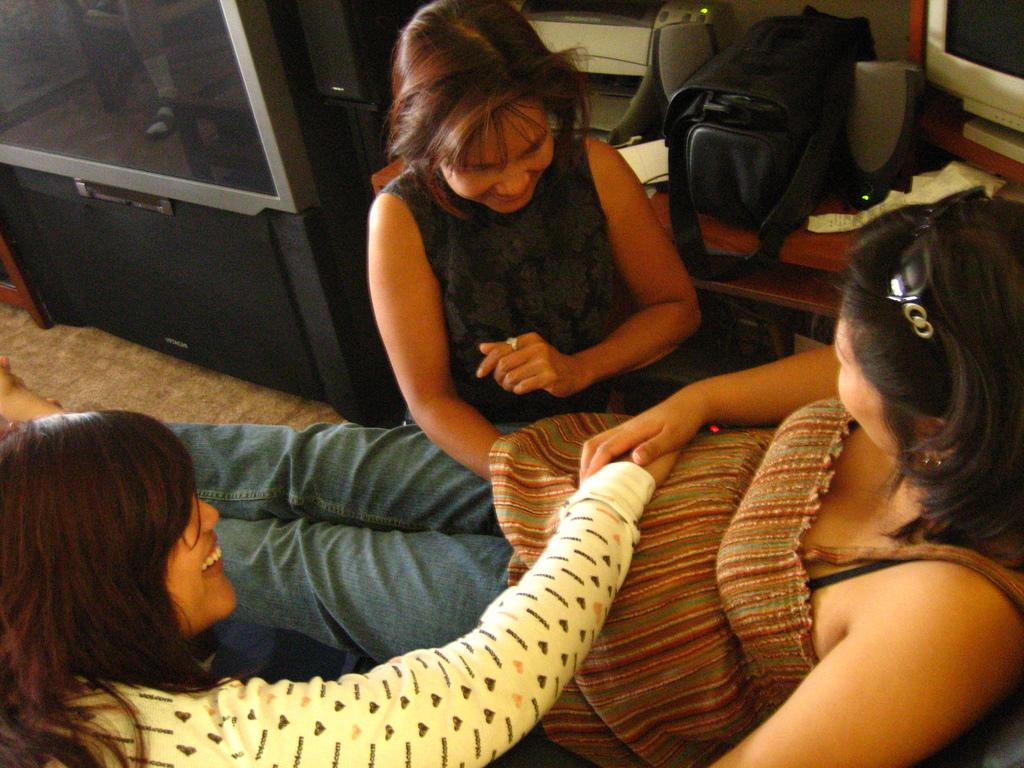How many people are in the image? There are three people in the image. Where are the people located in the image? The people are on the floor. What electronic device can be seen in the image? There is a monitor in the image. What object might be used for carrying items in the image? There is a bag in the image. What devices are used for producing sound in the image? There are speakers in the image. What other electronic device is visible in the background of the image? There is a television in the background of the image. What type of drug is being administered to the people in the image? There is no drug present in the image; it features three people on the floor with various electronic devices around them. 